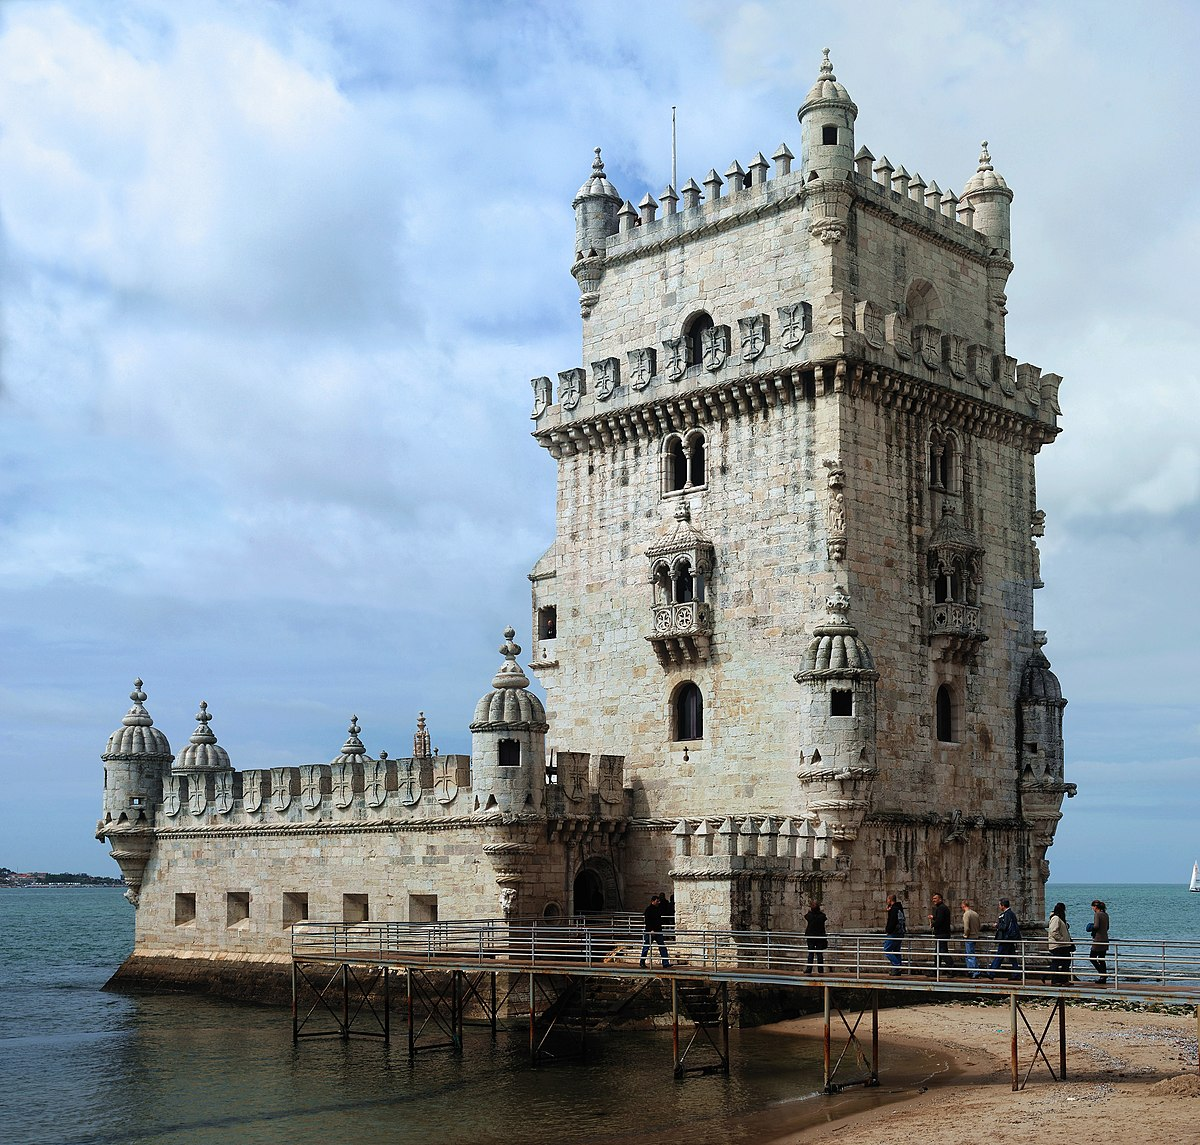Write a detailed description of the given image. The image presents the iconic Belem Tower, or Torre de Belem, located in Lisbon, Portugal. This historic tower stands as a testament to the Age of Discoveries, typically reflecting the Portuguese Manueline style characterized by elaborate sculptural details, maritime elements, and representations of the Discoveries. Constructed primarily of limestone, the tower's exterior is adorned with intricately carved stonework. Notable features include the ribbed window frames, Moorish-inspired watchtowers, and the battlements crowned with shields bearing the Cross of the Order of Christ. The image captures the tower from a vantage point that emphasizes its position on the edge of the Tagus River, surrounded on three sides by water. A narrow walkway connects the mainland to the tower, where several visitors can be seen walking and admiring this UNESCO World Heritage Site. The sky above is partly cloudy, casting natural light that enhances the texture of the stone and the serene blue of the water, creating a breathtaking and historically rich scene. 